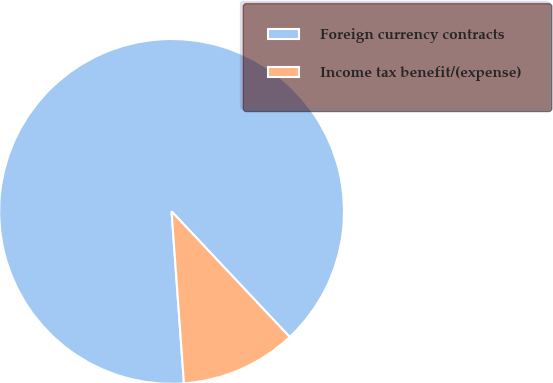Convert chart. <chart><loc_0><loc_0><loc_500><loc_500><pie_chart><fcel>Foreign currency contracts<fcel>Income tax benefit/(expense)<nl><fcel>89.13%<fcel>10.87%<nl></chart> 